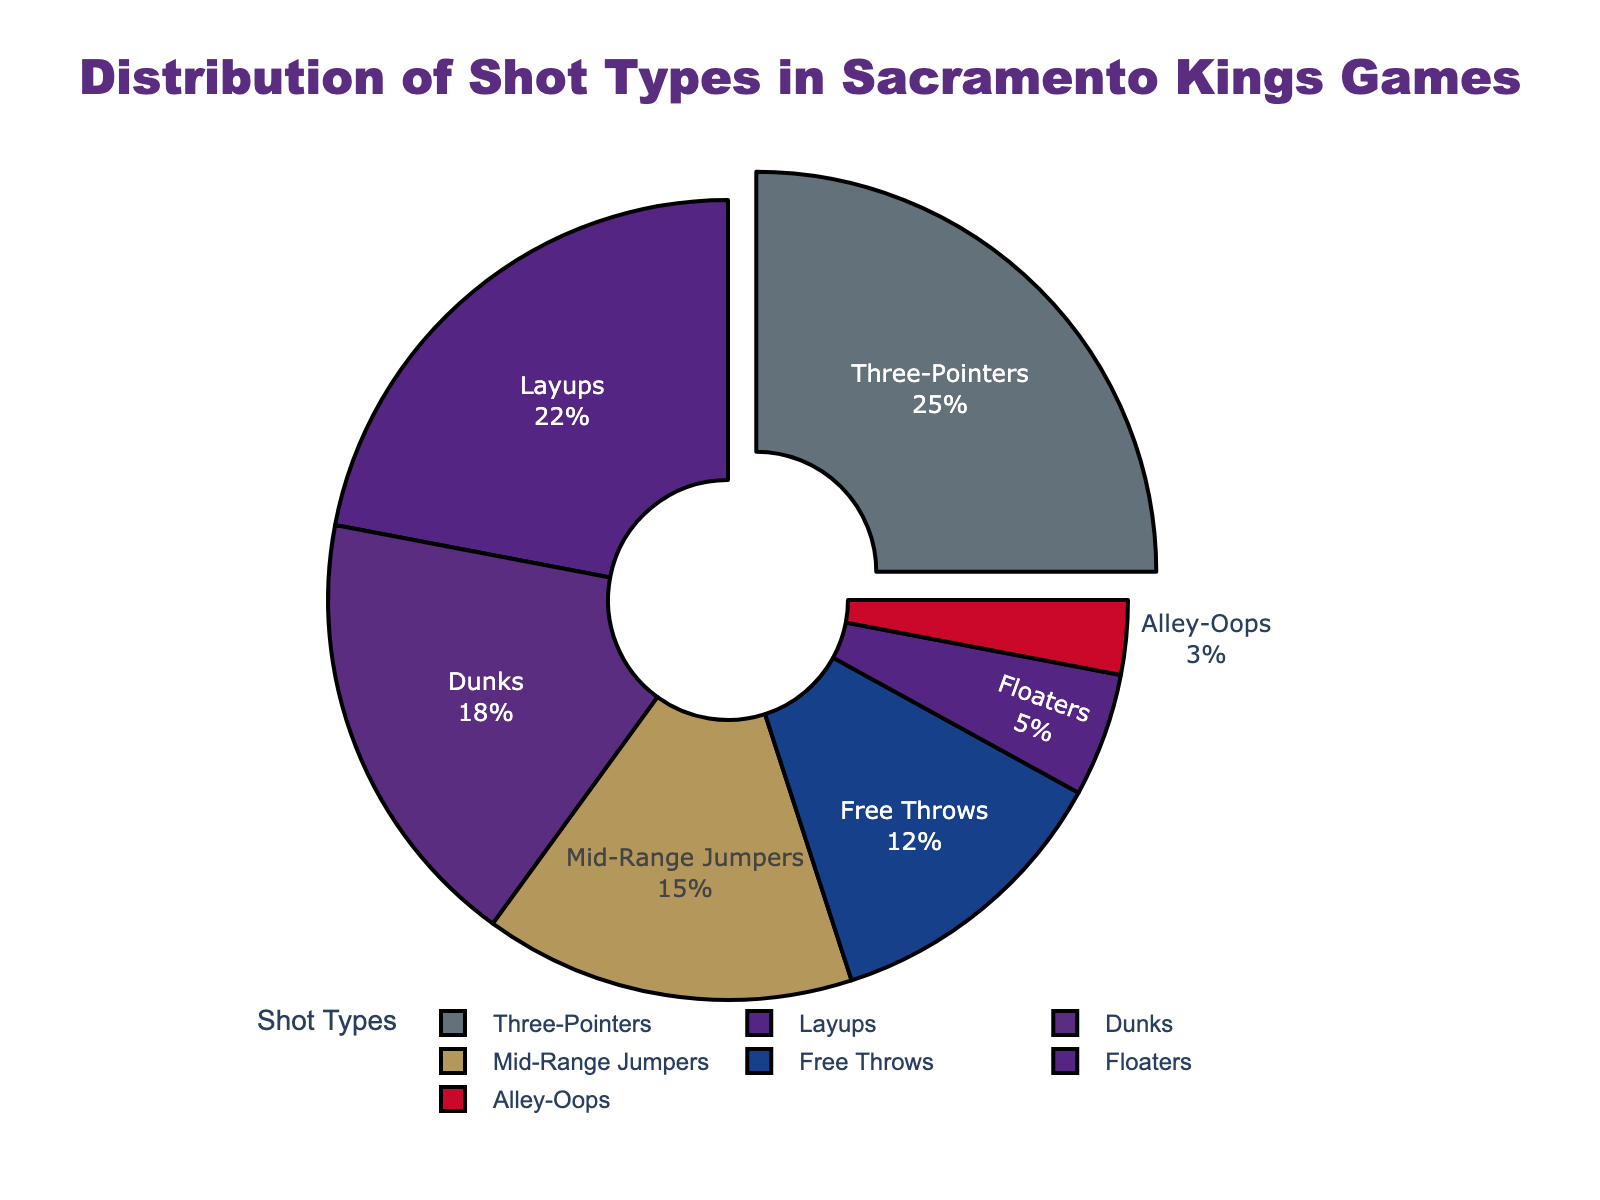Which shot type has the highest percentage? The figure shows that the shot type with the largest segment pulled out is the one with the highest percentage. The Three-Pointers segment is pulled out, indicating it has the highest value.
Answer: Three-Pointers What is the total percentage of layups and floaters combined? The percentage for layups is 22, and for floaters, it is 5. Adding these together gives us 22 + 5 = 27.
Answer: 27 Which shot types have a percentage lower than 10%? By looking at the smaller segments in the pie chart, the Alley-Oops (3%) and Floaters (5%) have percentages less than 10%.
Answer: Alley-Oops, Floaters Compare the percentages of dunks and mid-range jumpers. Which is higher and by how much? The percentage for dunks is 18, and the percentage for mid-range jumpers is 15. The difference is 18 - 15 = 3. Dunks are higher by 3%.
Answer: Dunks, 3 What is the percentage difference between the top two shot types? The top two shot types are Three-Pointers (25%) and Layups (22%). The percentage difference is 25 - 22 = 3.
Answer: 3 Are there more free throws or alley-oops, and by what margin? The percentage for free throws is 12, and for alley-oops, it is 3. The difference is 12 - 3 = 9. There are more free throws by 9%.
Answer: Free Throws, 9 What is the sum of the percentages of all shot types that have at least 20% representation? The shot types with at least 20% are Three-Pointers (25%) and Layups (22%). Their sum is 25 + 22 = 47.
Answer: 47 What percentage of shots are either dunks or three-pointers? The percentage of dunks is 18, and three-pointers is 25. Adding these together gives us 18 + 25 = 43.
Answer: 43 